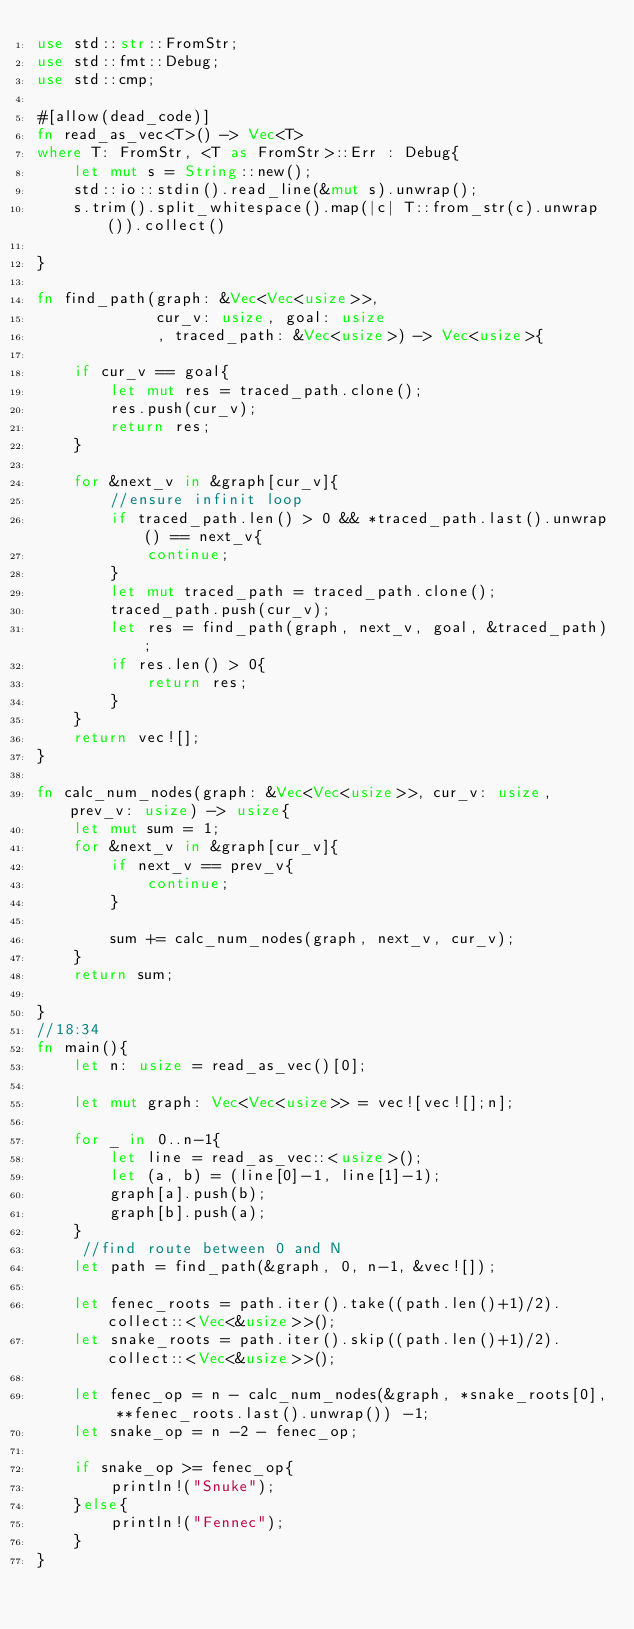<code> <loc_0><loc_0><loc_500><loc_500><_Rust_>use std::str::FromStr;
use std::fmt::Debug;
use std::cmp;

#[allow(dead_code)]
fn read_as_vec<T>() -> Vec<T>
where T: FromStr, <T as FromStr>::Err : Debug{
    let mut s = String::new();
    std::io::stdin().read_line(&mut s).unwrap();
    s.trim().split_whitespace().map(|c| T::from_str(c).unwrap()).collect()

}

fn find_path(graph: &Vec<Vec<usize>>,
             cur_v: usize, goal: usize
             , traced_path: &Vec<usize>) -> Vec<usize>{

    if cur_v == goal{
        let mut res = traced_path.clone();
        res.push(cur_v);
        return res;
    }

    for &next_v in &graph[cur_v]{
        //ensure infinit loop
        if traced_path.len() > 0 && *traced_path.last().unwrap() == next_v{
            continue;
        }
        let mut traced_path = traced_path.clone();
        traced_path.push(cur_v);
        let res = find_path(graph, next_v, goal, &traced_path);
        if res.len() > 0{
            return res;
        }
    }
    return vec![];
}

fn calc_num_nodes(graph: &Vec<Vec<usize>>, cur_v: usize, prev_v: usize) -> usize{
    let mut sum = 1;
    for &next_v in &graph[cur_v]{
        if next_v == prev_v{
            continue;
        }

        sum += calc_num_nodes(graph, next_v, cur_v);
    }
    return sum;

}
//18:34
fn main(){
    let n: usize = read_as_vec()[0];

    let mut graph: Vec<Vec<usize>> = vec![vec![];n];

    for _ in 0..n-1{
        let line = read_as_vec::<usize>();
        let (a, b) = (line[0]-1, line[1]-1);
        graph[a].push(b);
        graph[b].push(a);
    }
     //find route between 0 and N
    let path = find_path(&graph, 0, n-1, &vec![]);

    let fenec_roots = path.iter().take((path.len()+1)/2).collect::<Vec<&usize>>();
    let snake_roots = path.iter().skip((path.len()+1)/2).collect::<Vec<&usize>>();

    let fenec_op = n - calc_num_nodes(&graph, *snake_roots[0], **fenec_roots.last().unwrap()) -1;
    let snake_op = n -2 - fenec_op;

    if snake_op >= fenec_op{
        println!("Snuke");
    }else{
        println!("Fennec");
    }
}
</code> 